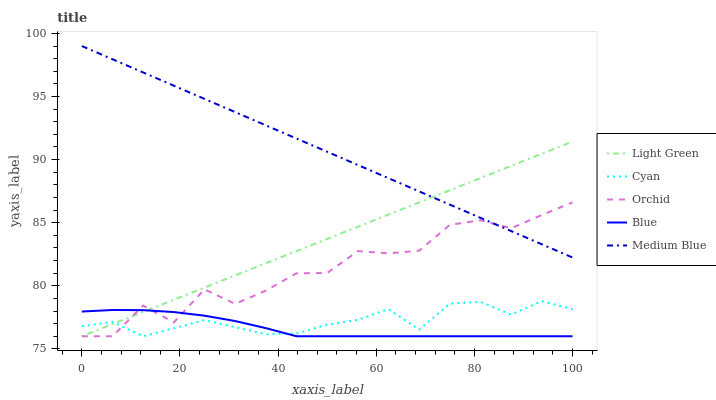Does Blue have the minimum area under the curve?
Answer yes or no. Yes. Does Medium Blue have the maximum area under the curve?
Answer yes or no. Yes. Does Cyan have the minimum area under the curve?
Answer yes or no. No. Does Cyan have the maximum area under the curve?
Answer yes or no. No. Is Medium Blue the smoothest?
Answer yes or no. Yes. Is Orchid the roughest?
Answer yes or no. Yes. Is Cyan the smoothest?
Answer yes or no. No. Is Cyan the roughest?
Answer yes or no. No. Does Medium Blue have the lowest value?
Answer yes or no. No. Does Medium Blue have the highest value?
Answer yes or no. Yes. Does Cyan have the highest value?
Answer yes or no. No. Is Blue less than Medium Blue?
Answer yes or no. Yes. Is Medium Blue greater than Blue?
Answer yes or no. Yes. Does Orchid intersect Blue?
Answer yes or no. Yes. Is Orchid less than Blue?
Answer yes or no. No. Is Orchid greater than Blue?
Answer yes or no. No. Does Blue intersect Medium Blue?
Answer yes or no. No. 